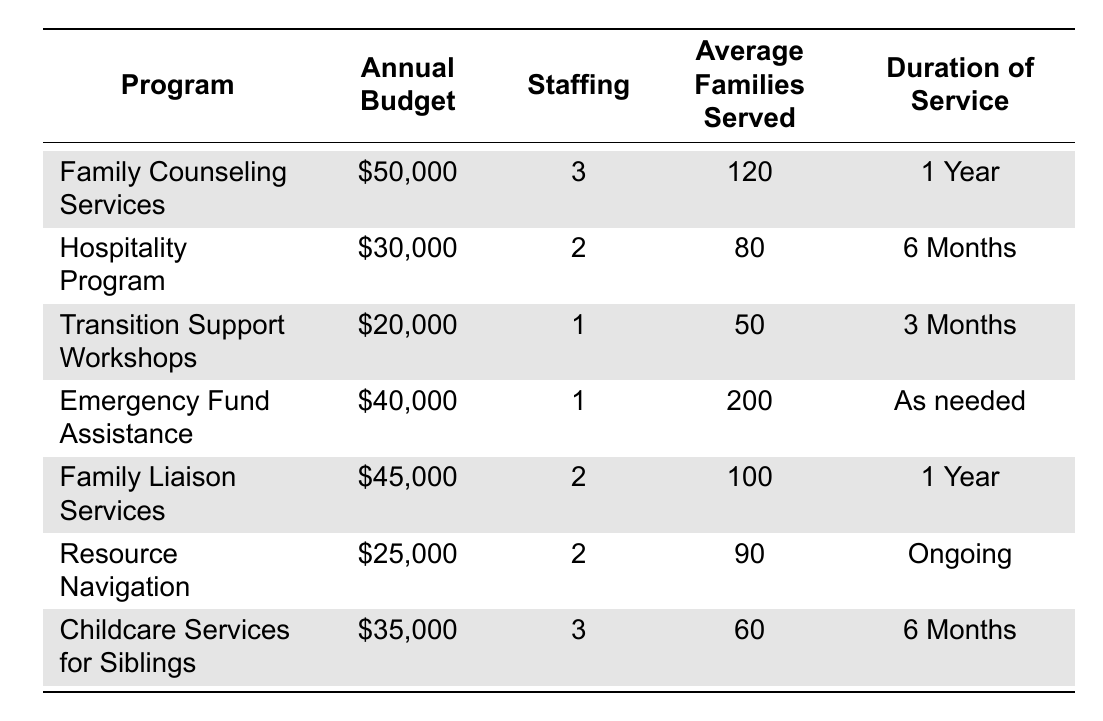What is the annual budget for the Family Counseling Services program? The table lists the budget for the Family Counseling Services program as $50,000 under the "Annual Budget" column.
Answer: $50,000 How many families are served on average by the Resource Navigation program? The "Average Families Served" column for the Resource Navigation program shows a number of 90, indicating that this program serves 90 families on average.
Answer: 90 What is the total annual budget allocated for all programs listed in the table? The annual budgets for each program are summed up: $50,000 + $30,000 + $20,000 + $40,000 + $45,000 + $25,000 + $35,000 = $245,000.
Answer: $245,000 Are there any programs with the same number of staff? The Family Counseling Services and Childcare Services for Siblings both have 3 staff members, which confirms that there are programs with the same staffing levels.
Answer: Yes What is the average duration of service across all programs? The program durations need to be categorized: 1 Year (2 programs), 6 Months (2 programs), 3 Months (1 program), Ongoing (1 program), and As needed (1 program). The average is calculated: (2*1 + 2*0.5 + 1*0.25 + 1*1 + 1*0) / 7 = 0.54 years, which is approximately 6.5 months.
Answer: Approximately 6.5 months Which program serves the highest number of families, and how many families does it serve? Looking at the "Average Families Served" column, the Emergency Fund Assistance program has the highest number, serving 200 families.
Answer: Emergency Fund Assistance; 200 families Is the Family Liaison Services program more expensive than the Hospitality Program? The Family Liaison Services program has an annual budget of $45,000, while the Hospitality Program has $30,000. Since $45,000 is greater than $30,000, Family Liaison Services is more expensive.
Answer: Yes What is the total number of staff across all programs? By adding the staffing numbers for each program: 3 + 2 + 1 + 1 + 2 + 2 + 3 = 14 staff members total across all programs.
Answer: 14 Which program has the shortest duration of service? The Transition Support Workshops and the Hospitality Program both have 3 and 6 months, respectively, but the Transition Support Workshops has a duration of only 3 months, making it the shortest.
Answer: Transition Support Workshops How many families does the Childcare Services for Siblings program serve compared to the Family Counseling Services program? The Childcare Services for Siblings program serves 60 families, while the Family Counseling Services program serves 120 families. Comparing these, Family Counseling Services serves 120 - 60 = 60 more families.
Answer: 60 more families 